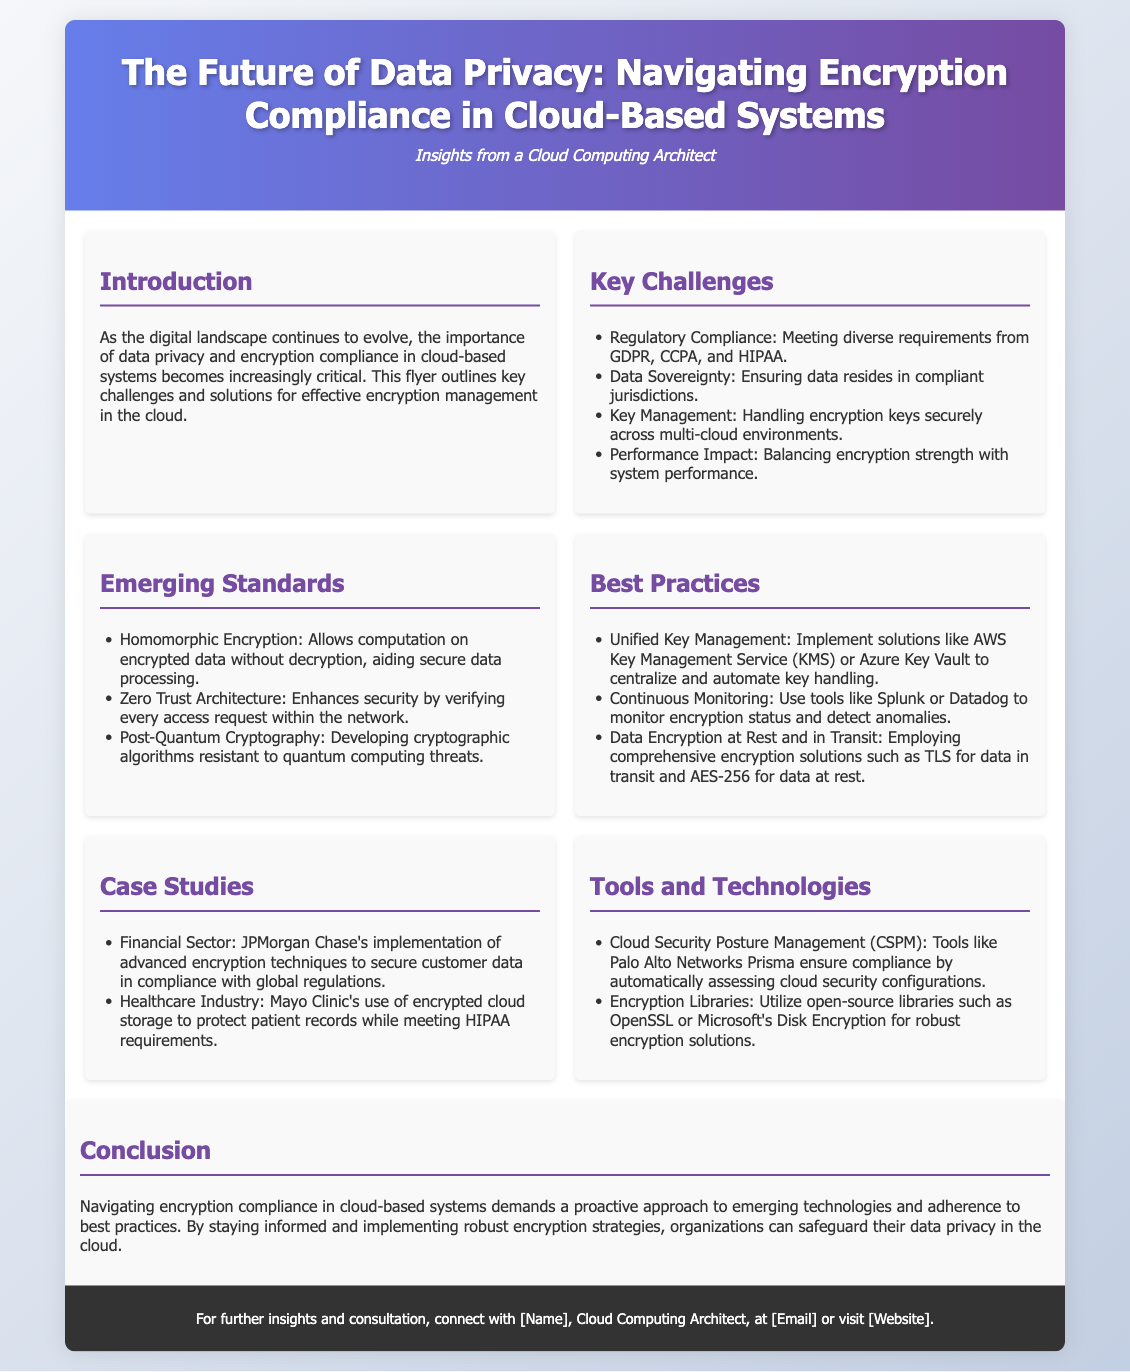What is the main focus of the document? The document discusses the future of data privacy and encryption compliance in cloud-based systems.
Answer: Data privacy and encryption compliance What are two regulatory compliance requirements mentioned? The document lists regulatory requirements including GDPR and CCPA among others.
Answer: GDPR, CCPA What technology is highlighted for secure data processing? The document mentions homomorphic encryption as a technology for secure data processing.
Answer: Homomorphic encryption What is one of the best practices regarding key management? The best practices section suggests implementing solutions like AWS Key Management Service for centralized key management.
Answer: AWS Key Management Service Which sector did JPMorgan Chase serve as a case study example? The document states that JPMorgan Chase is from the financial sector in its case studies section.
Answer: Financial Sector What type of architecture enhances security according to the document? The document refers to zero trust architecture as a method that enhances security.
Answer: Zero Trust Architecture What encryption method is recommended for data at rest? The document suggests using AES-256 for data at rest.
Answer: AES-256 What is the purpose of Cloud Security Posture Management tools? The document states that CSPM tools automatically assess cloud security configurations to ensure compliance.
Answer: Ensure compliance Which healthcare organization is mentioned in relation to HIPAA compliance? The document highlights Mayo Clinic as an organization that uses encrypted cloud storage for HIPAA compliance.
Answer: Mayo Clinic 